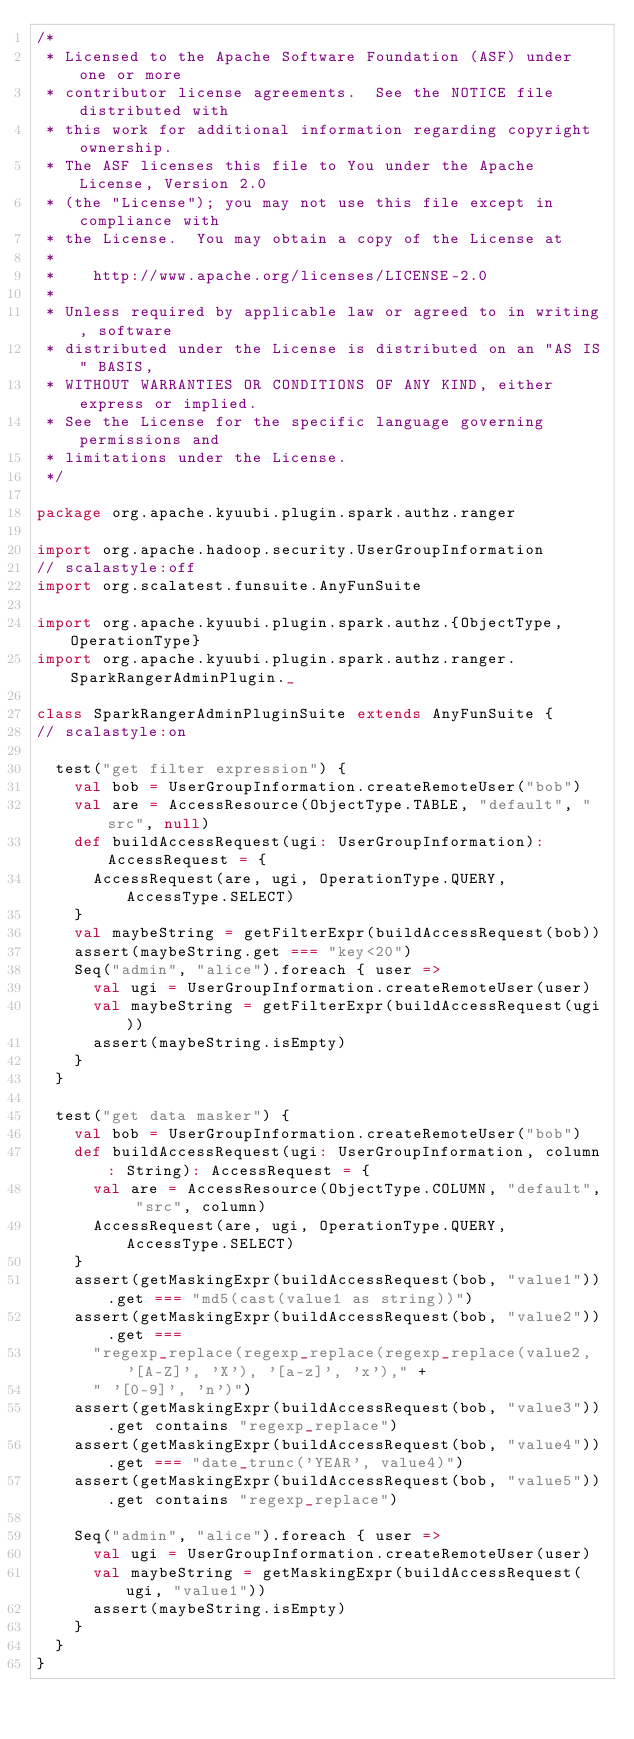<code> <loc_0><loc_0><loc_500><loc_500><_Scala_>/*
 * Licensed to the Apache Software Foundation (ASF) under one or more
 * contributor license agreements.  See the NOTICE file distributed with
 * this work for additional information regarding copyright ownership.
 * The ASF licenses this file to You under the Apache License, Version 2.0
 * (the "License"); you may not use this file except in compliance with
 * the License.  You may obtain a copy of the License at
 *
 *    http://www.apache.org/licenses/LICENSE-2.0
 *
 * Unless required by applicable law or agreed to in writing, software
 * distributed under the License is distributed on an "AS IS" BASIS,
 * WITHOUT WARRANTIES OR CONDITIONS OF ANY KIND, either express or implied.
 * See the License for the specific language governing permissions and
 * limitations under the License.
 */

package org.apache.kyuubi.plugin.spark.authz.ranger

import org.apache.hadoop.security.UserGroupInformation
// scalastyle:off
import org.scalatest.funsuite.AnyFunSuite

import org.apache.kyuubi.plugin.spark.authz.{ObjectType, OperationType}
import org.apache.kyuubi.plugin.spark.authz.ranger.SparkRangerAdminPlugin._

class SparkRangerAdminPluginSuite extends AnyFunSuite {
// scalastyle:on

  test("get filter expression") {
    val bob = UserGroupInformation.createRemoteUser("bob")
    val are = AccessResource(ObjectType.TABLE, "default", "src", null)
    def buildAccessRequest(ugi: UserGroupInformation): AccessRequest = {
      AccessRequest(are, ugi, OperationType.QUERY, AccessType.SELECT)
    }
    val maybeString = getFilterExpr(buildAccessRequest(bob))
    assert(maybeString.get === "key<20")
    Seq("admin", "alice").foreach { user =>
      val ugi = UserGroupInformation.createRemoteUser(user)
      val maybeString = getFilterExpr(buildAccessRequest(ugi))
      assert(maybeString.isEmpty)
    }
  }

  test("get data masker") {
    val bob = UserGroupInformation.createRemoteUser("bob")
    def buildAccessRequest(ugi: UserGroupInformation, column: String): AccessRequest = {
      val are = AccessResource(ObjectType.COLUMN, "default", "src", column)
      AccessRequest(are, ugi, OperationType.QUERY, AccessType.SELECT)
    }
    assert(getMaskingExpr(buildAccessRequest(bob, "value1")).get === "md5(cast(value1 as string))")
    assert(getMaskingExpr(buildAccessRequest(bob, "value2")).get ===
      "regexp_replace(regexp_replace(regexp_replace(value2, '[A-Z]', 'X'), '[a-z]', 'x')," +
      " '[0-9]', 'n')")
    assert(getMaskingExpr(buildAccessRequest(bob, "value3")).get contains "regexp_replace")
    assert(getMaskingExpr(buildAccessRequest(bob, "value4")).get === "date_trunc('YEAR', value4)")
    assert(getMaskingExpr(buildAccessRequest(bob, "value5")).get contains "regexp_replace")

    Seq("admin", "alice").foreach { user =>
      val ugi = UserGroupInformation.createRemoteUser(user)
      val maybeString = getMaskingExpr(buildAccessRequest(ugi, "value1"))
      assert(maybeString.isEmpty)
    }
  }
}
</code> 